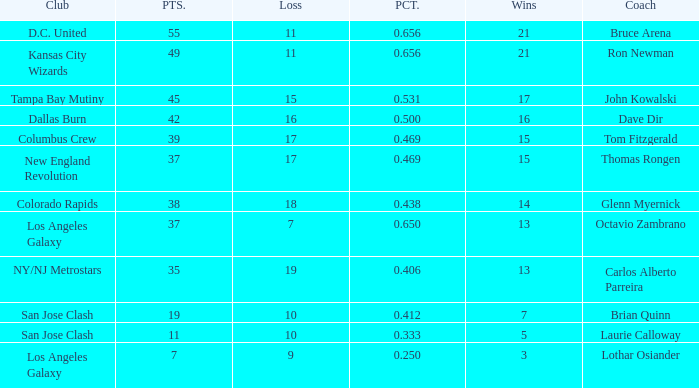What is the highest percent of Bruce Arena when he loses more than 11 games? None. 